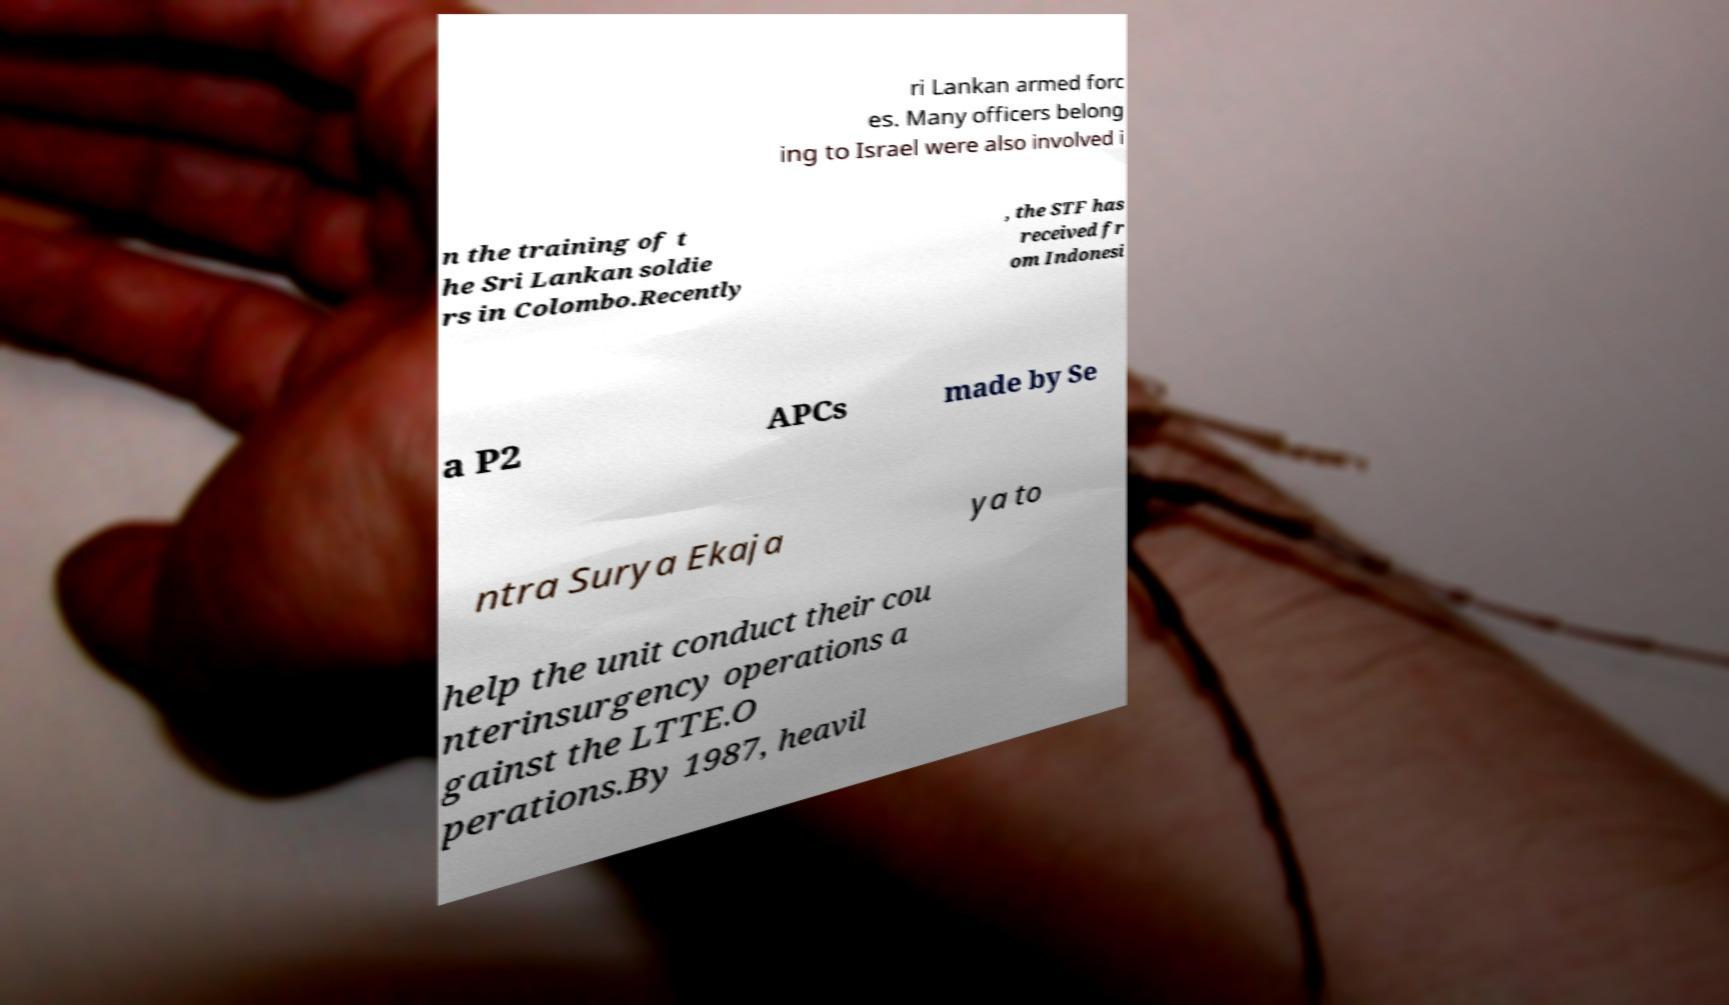There's text embedded in this image that I need extracted. Can you transcribe it verbatim? ri Lankan armed forc es. Many officers belong ing to Israel were also involved i n the training of t he Sri Lankan soldie rs in Colombo.Recently , the STF has received fr om Indonesi a P2 APCs made by Se ntra Surya Ekaja ya to help the unit conduct their cou nterinsurgency operations a gainst the LTTE.O perations.By 1987, heavil 